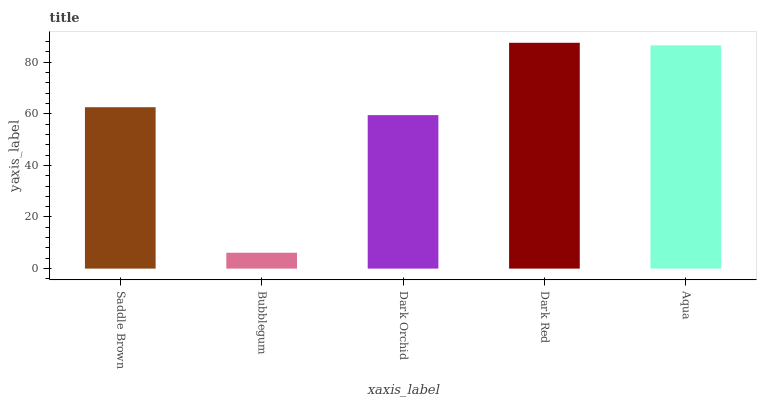Is Bubblegum the minimum?
Answer yes or no. Yes. Is Dark Red the maximum?
Answer yes or no. Yes. Is Dark Orchid the minimum?
Answer yes or no. No. Is Dark Orchid the maximum?
Answer yes or no. No. Is Dark Orchid greater than Bubblegum?
Answer yes or no. Yes. Is Bubblegum less than Dark Orchid?
Answer yes or no. Yes. Is Bubblegum greater than Dark Orchid?
Answer yes or no. No. Is Dark Orchid less than Bubblegum?
Answer yes or no. No. Is Saddle Brown the high median?
Answer yes or no. Yes. Is Saddle Brown the low median?
Answer yes or no. Yes. Is Dark Red the high median?
Answer yes or no. No. Is Bubblegum the low median?
Answer yes or no. No. 